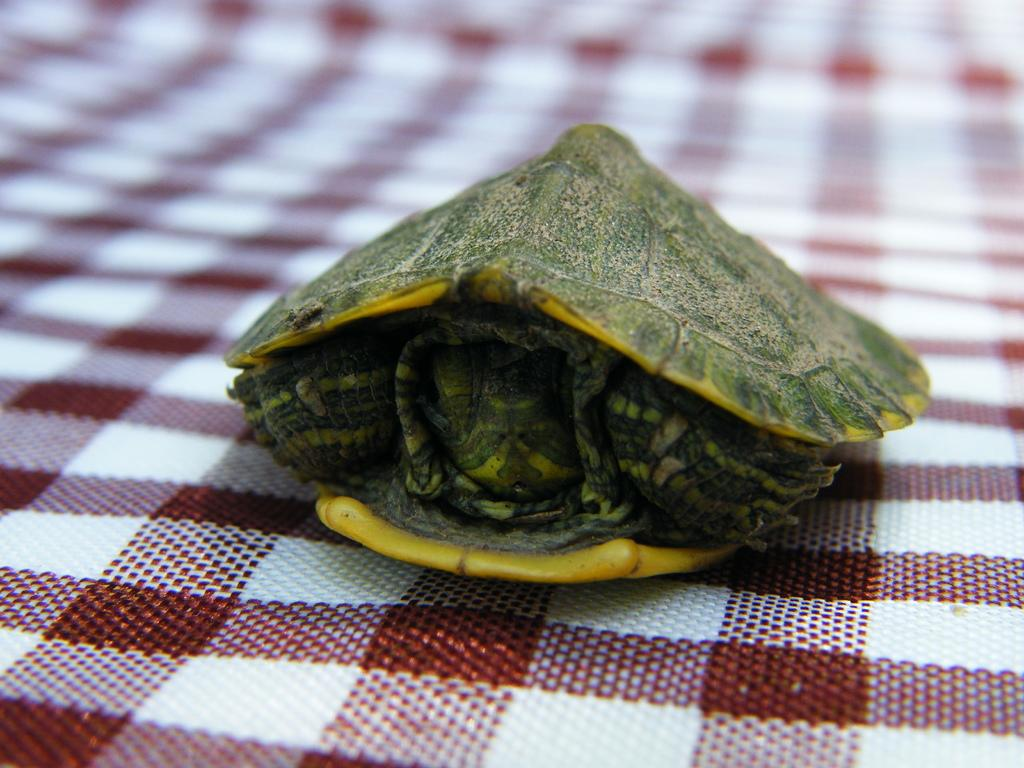What type of animal is in the picture? There is a turtle in the picture. What is a distinctive feature of the turtle? The turtle has a hard shell. What is the turtle placed on in the picture? The turtle is placed on a white and brown checked cloth. What type of sponge is being used to clean the turtle in the image? There is no sponge or cleaning activity depicted in the image; it only shows a turtle with a hard shell placed on a white and brown checked cloth. 